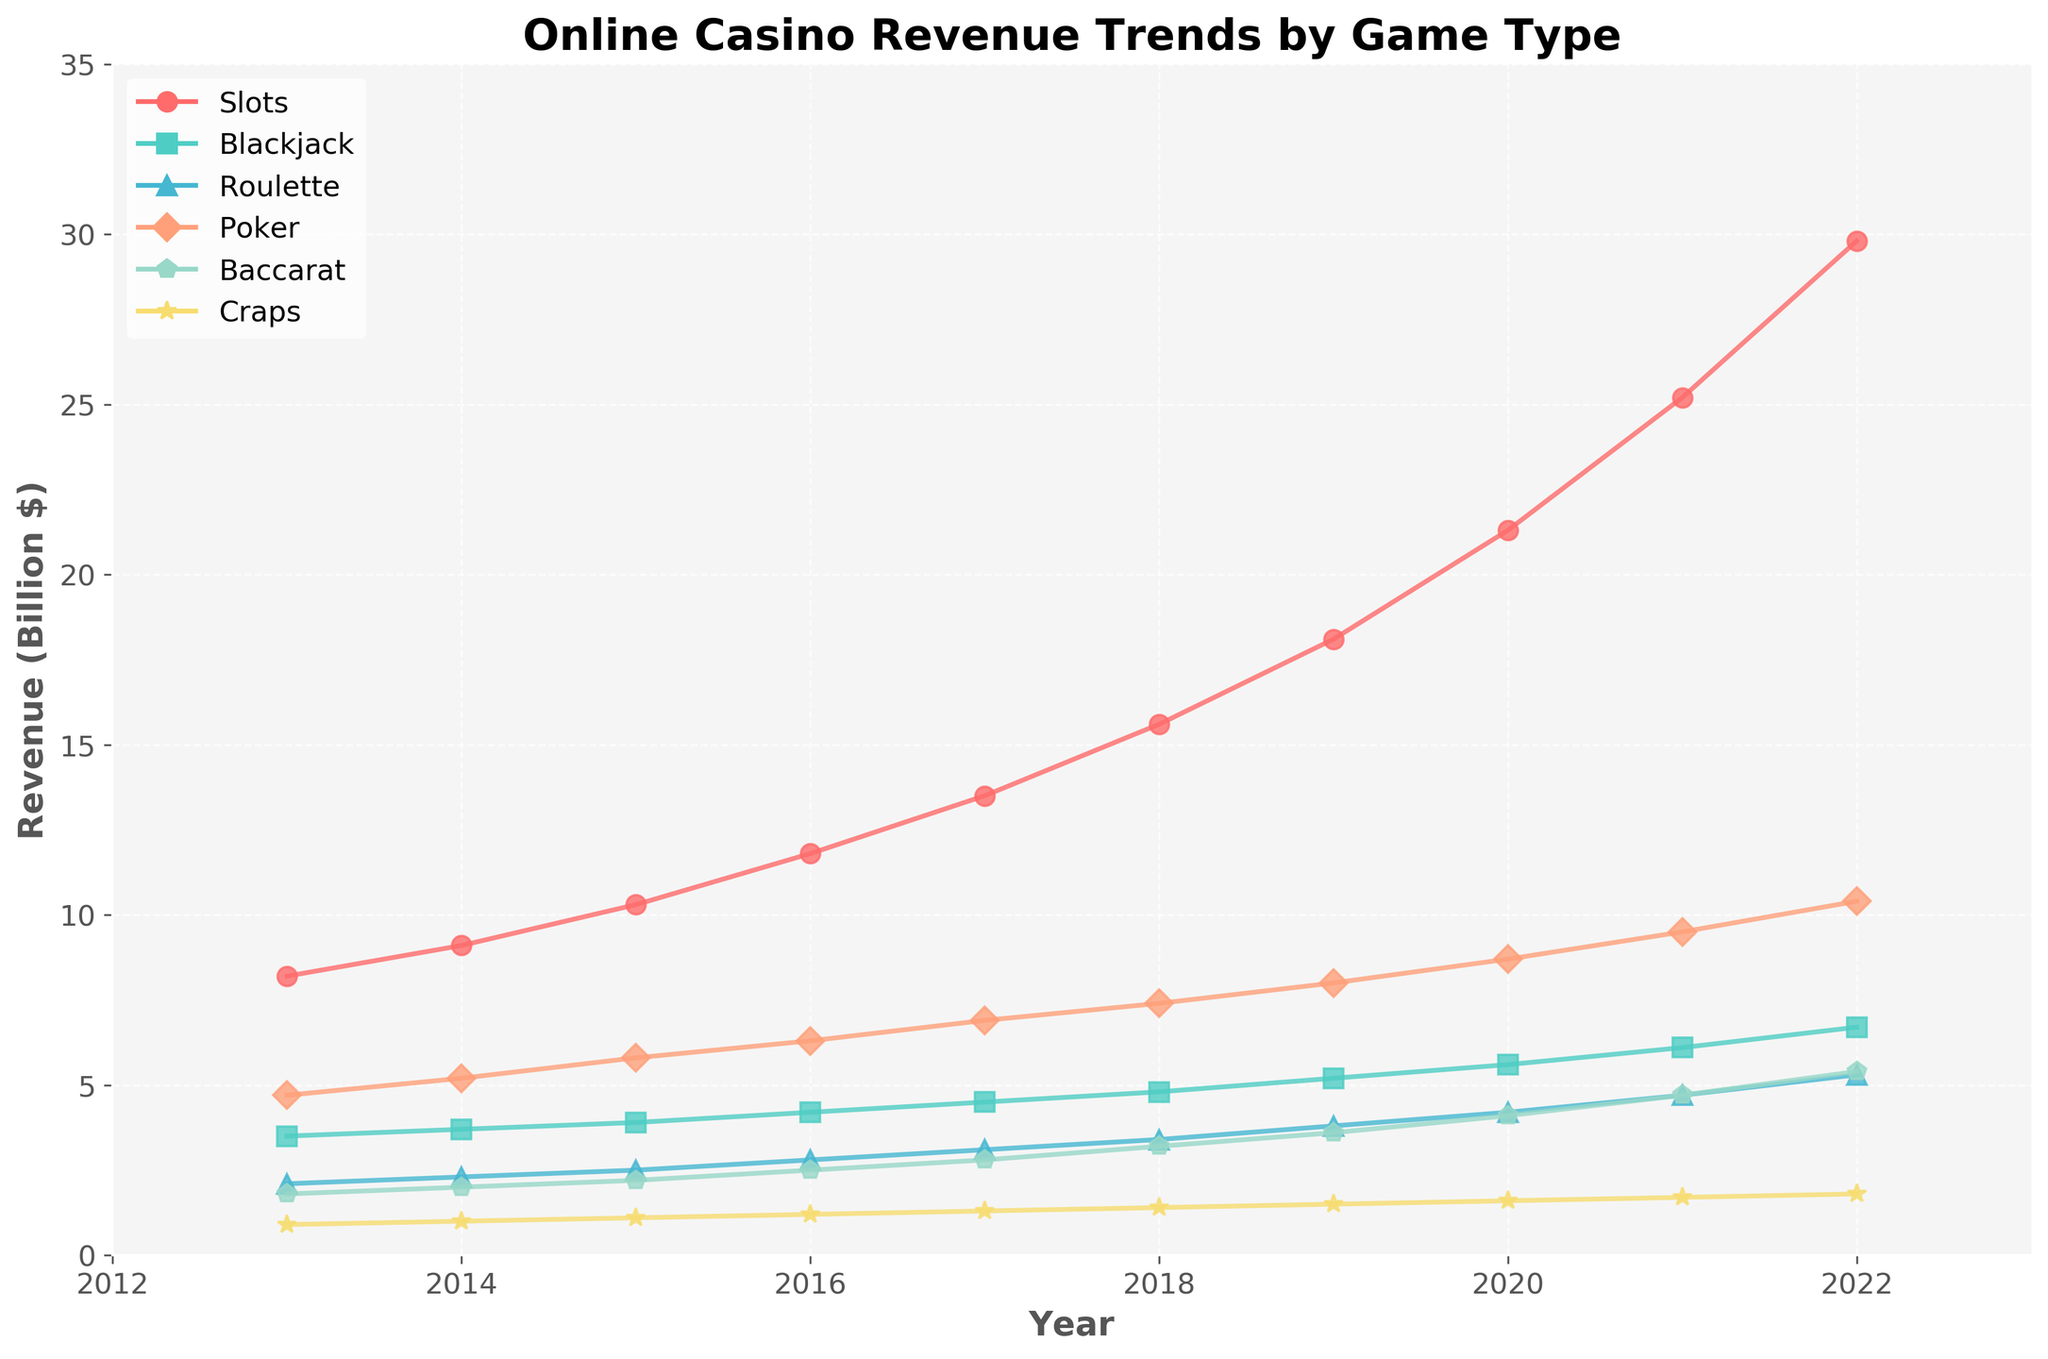What is the overall trend in online casino revenue for slot games from 2013 to 2022? By examining the line representing slot games, we see a consistent upward trend every year, indicating that revenue from slot games has been increasing steadily over the years.
Answer: Increasing Which game type had the highest revenue in 2022? Look at the last year (2022) on the graph and identify which line is at the highest point. The line for slot games reaches the highest position.
Answer: Slots How much did the revenue for poker games increase from 2013 to 2022? The revenue for poker in 2013 was 4.7 billion and in 2022 it was 10.4 billion. The increase is calculated as 10.4 - 4.7 = 5.7 billion.
Answer: 5.7 billion In which year did baccarat games have the same revenue as craps? By inspecting the two lines for baccarat and craps, they intersect in the year 2017, indicating equal revenue.
Answer: 2017 Arrange the game types in descending order of revenue in 2020. In 2020, the revenues for games are: Slots (21.3), Poker (8.7), Blackjack (5.6), Baccarat (4.1), Roulette (4.2), Craps (1.6). Correctly sorted, it becomes Slots > Poker > Blackjack > Roulette > Baccarat > Craps.
Answer: Slots, Poker, Blackjack, Roulette, Baccarat, Craps What is the average revenue for blackjack from 2013 to 2022? Sum the revenues for blackjack from 2013 to 2022 and divide by the number of years: (3.5 + 3.7 + 3.9 + 4.2 + 4.5 + 4.8 + 5.2 + 5.6 + 6.1 + 6.7) / 10 = 4.62 billion.
Answer: 4.62 billion Which game type had the least growth in revenue from 2013 to 2022? Calculate the growth by subtracting the 2013 revenue from the 2022 revenue for each game type. The game with the smallest difference has the least growth. Craps: 1.8 - 0.9 = 0.9 billion. Craps show the least growth.
Answer: Craps By what percentage did the revenue for roulette games increase from 2013 to 2022? Calculate the percentage increase = [(Revenue in 2022 - Revenue in 2013) / Revenue in 2013] * 100. For roulette: [(5.3 - 2.1) / 2.1] * 100 = 152.38%.
Answer: 152.38% Which game type saw the largest single-year increase in revenue? Examine the graph to find the steepest line segment. Slot games show the steepest incline between 2021 and 2022: 29.8 - 25.2 = 4.6 billion increase.
Answer: Slots Between 2015 and 2018, which game type had the highest total revenue? Sum the revenues for each game type over the specified years and compare. Slots: 10.3 + 11.8 + 13.5 + 15.6 = 51.2 billion; Blackjack: 3.9 + 4.2 + 4.5 + 4.8 = 17.4 billion; Roulette: 2.5 + 2.8 + 3.1 + 3.4 = 11.8 billion; Poker: 5.8 + 6.3 + 6.9 + 7.4 = 26.4 billion; Baccarat: 2.2 + 2.5 + 2.8 + 3.2 = 10.7 billion; Craps: 1.1 + 1.2 + 1.3 + 1.4 = 5.0 billion. Slots had the highest total.
Answer: Slots 